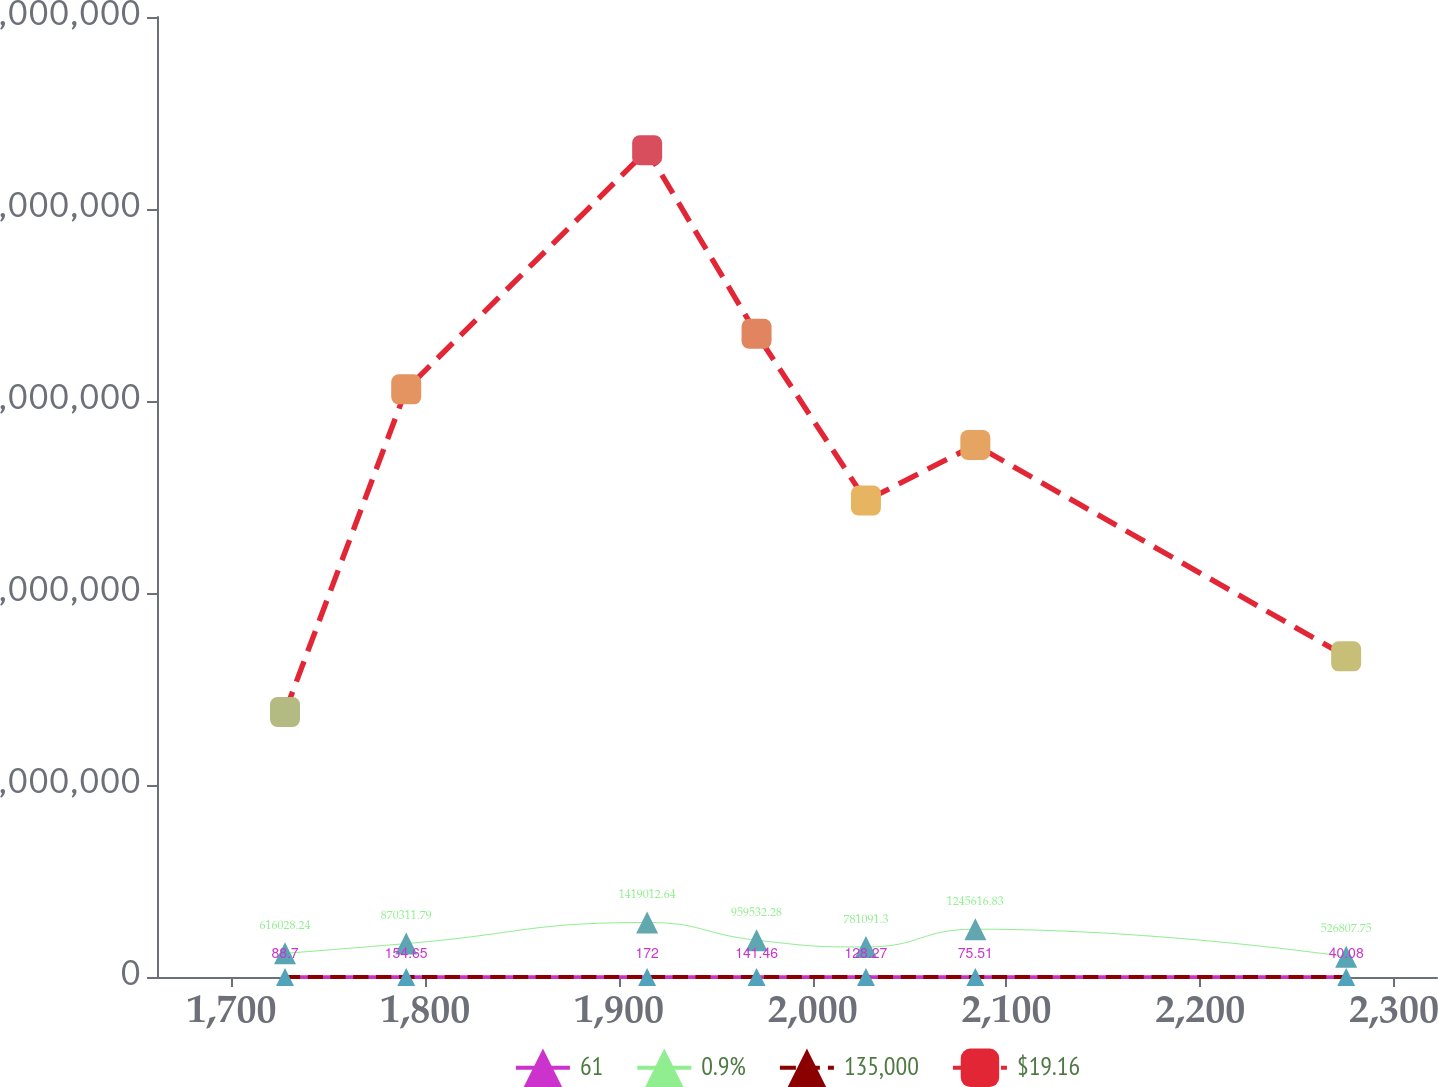<chart> <loc_0><loc_0><loc_500><loc_500><line_chart><ecel><fcel>61<fcel>0.9%<fcel>135,000<fcel>$19.16<nl><fcel>1727.67<fcel>88.7<fcel>616028<fcel>3.53<fcel>6.90222e+06<nl><fcel>1790.23<fcel>154.65<fcel>870312<fcel>4.02<fcel>1.53037e+07<nl><fcel>1914.57<fcel>172<fcel>1.41901e+06<fcel>7.97<fcel>2.15304e+07<nl><fcel>1971.03<fcel>141.46<fcel>959532<fcel>5<fcel>1.6752e+07<nl><fcel>2027.49<fcel>128.27<fcel>781091<fcel>4.51<fcel>1.24073e+07<nl><fcel>2083.95<fcel>75.51<fcel>1.24562e+06<fcel>5.98<fcel>1.38555e+07<nl><fcel>2275.32<fcel>40.08<fcel>526808<fcel>3.04<fcel>8.35046e+06<nl><fcel>2331.79<fcel>115.08<fcel>1.1564e+06<fcel>5.49<fcel>1.8634e+07<nl><fcel>2388.26<fcel>101.89<fcel>1.06718e+06<fcel>7.15<fcel>2.00822e+07<nl></chart> 